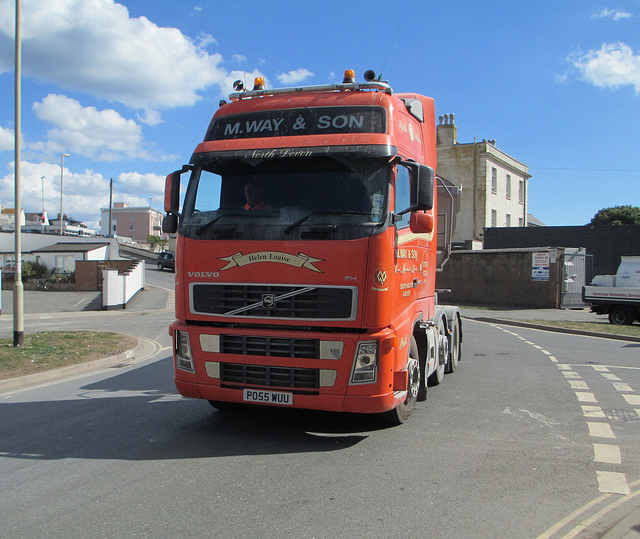Identify the text contained in this image. VOLVO PO55 WUU SON &amp; WAY S M 